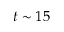Convert formula to latex. <formula><loc_0><loc_0><loc_500><loc_500>t \sim 1 5</formula> 